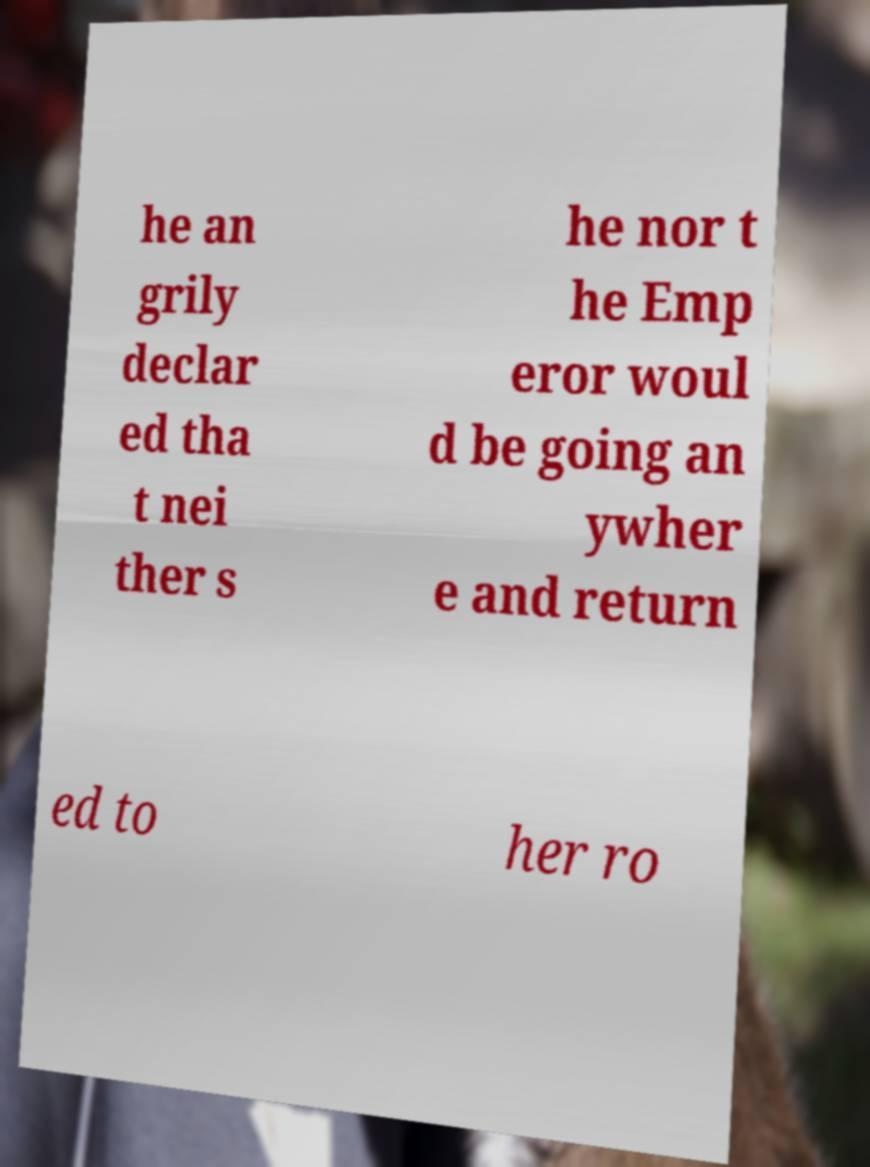Could you assist in decoding the text presented in this image and type it out clearly? he an grily declar ed tha t nei ther s he nor t he Emp eror woul d be going an ywher e and return ed to her ro 